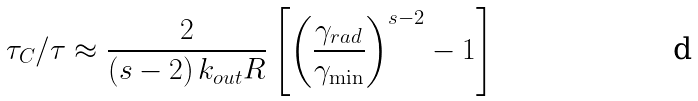Convert formula to latex. <formula><loc_0><loc_0><loc_500><loc_500>\tau _ { C } / \tau \approx \frac { 2 } { ( s - 2 ) \, k _ { o u t } R } \left [ \left ( \frac { \gamma _ { r a d } } { \gamma _ { \min } } \right ) ^ { s - 2 } - 1 \right ]</formula> 